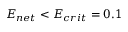Convert formula to latex. <formula><loc_0><loc_0><loc_500><loc_500>E _ { n e t } < E _ { c r i t } = 0 . 1</formula> 